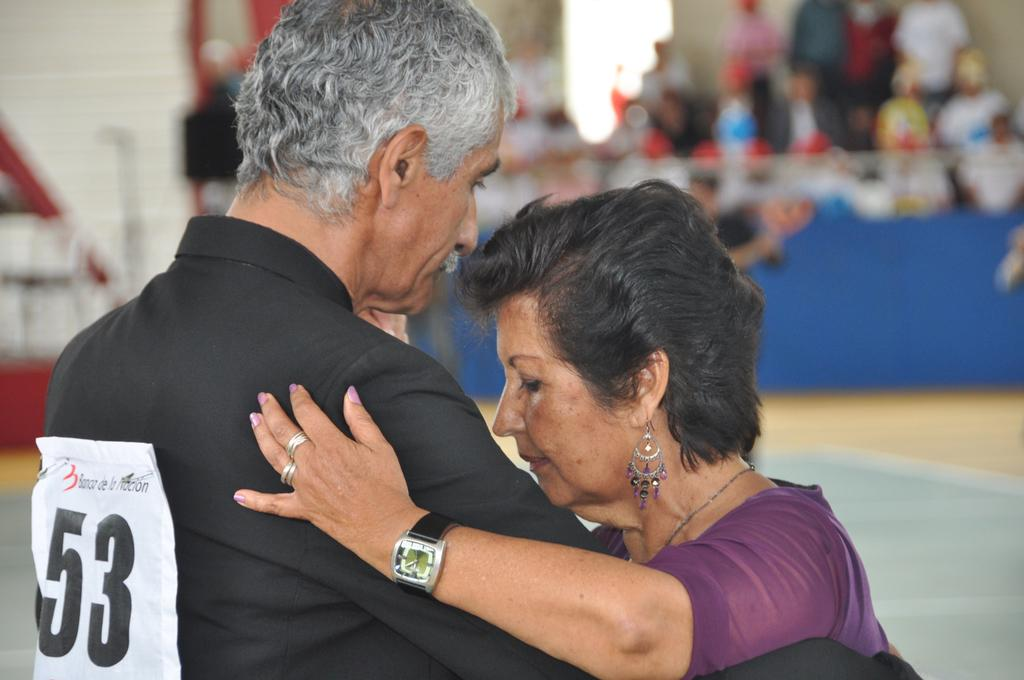Provide a one-sentence caption for the provided image. A woman and man wearing number 53 on his back dancing. 